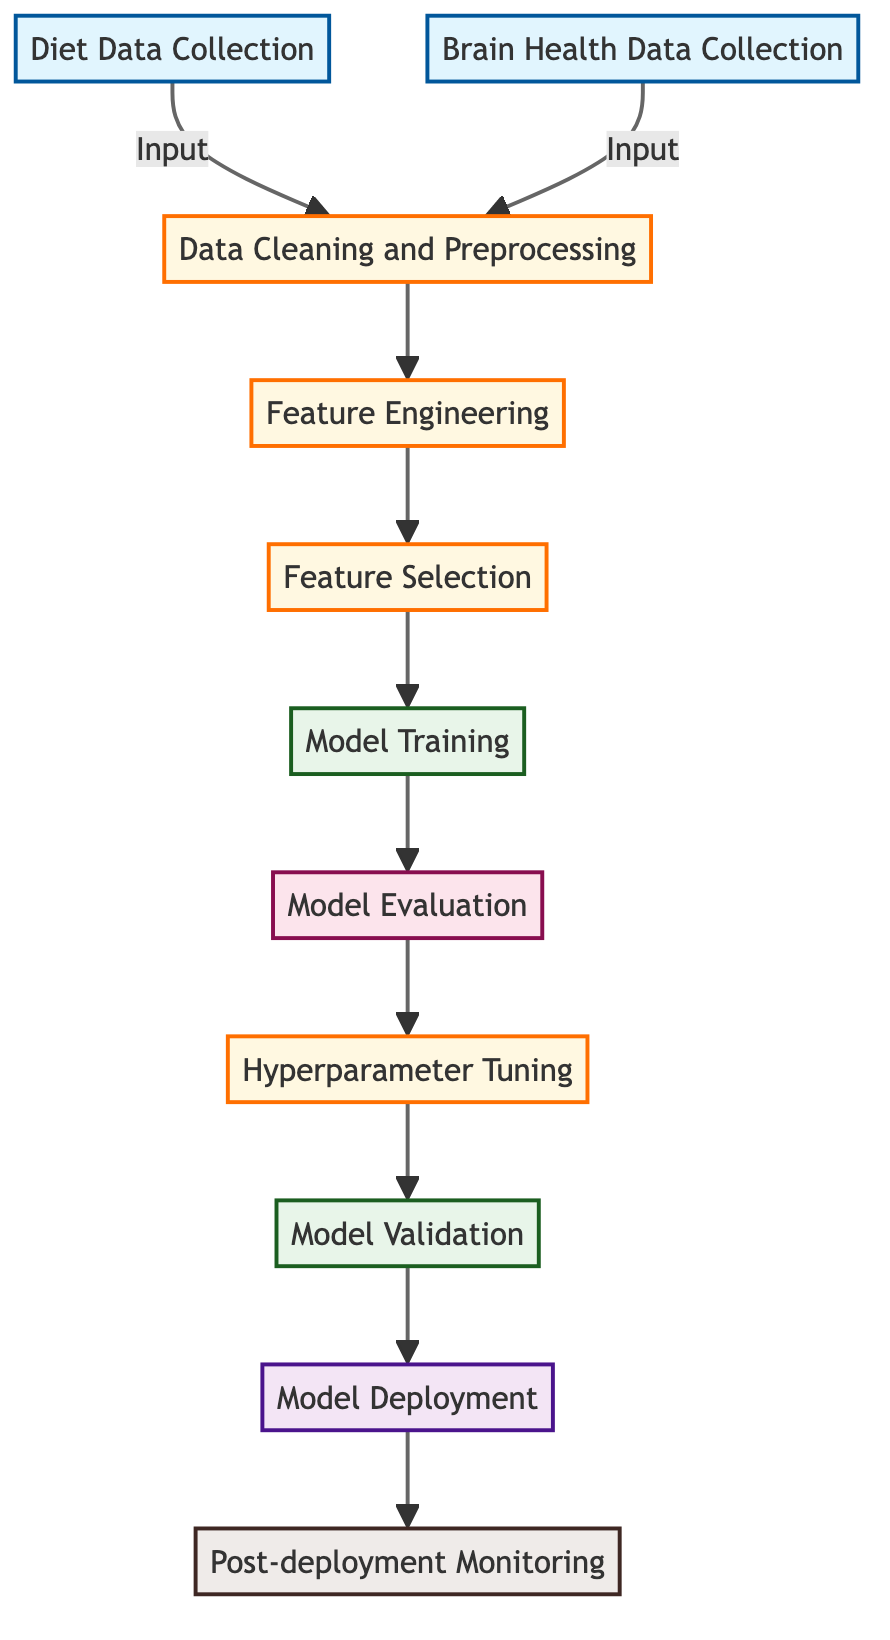What is the first step in the workflow? The first step in the workflow is "Diet Data Collection", which is represented as the first node in the flowchart.
Answer: Diet Data Collection How many data input nodes are there? There are two data input nodes in the diagram: "Diet Data Collection" and "Brain Health Data Collection".
Answer: 2 What is the last step in the workflow? The last step in the workflow is "Post-deployment Monitoring", indicated as the final node in the flowchart.
Answer: Post-deployment Monitoring Which node involves generating relevant features? The node involving generating relevant features is "Feature Engineering". This is connected to the data preprocessing steps and occurs after data cleaning.
Answer: Feature Engineering What is the main purpose of the "Model Evaluation" step? "Model Evaluation" serves the purpose of assessing the machine learning model's performance using various metrics. This is an essential step before further processing like hyperparameter tuning.
Answer: Evaluate model performance How many total processing steps are there? There are five processing steps in the workflow: "Data Cleaning and Preprocessing", "Feature Engineering", "Feature Selection", "Hyperparameter Tuning", and "Model Validation".
Answer: 5 What step follows "Model Training"? The step that follows "Model Training" is "Model Evaluation". This denotes the transition from the training phase to assessing the quality of the trained model.
Answer: Model Evaluation What is the function of "Hyperparameter Tuning"? "Hyperparameter Tuning" optimizes the model parameters to improve its performance, which is critical for ensuring the model generalizes well on unseen data.
Answer: Optimize model parameters What type of analysis is performed during "Feature Selection"? In "Feature Selection", statistical tests or algorithms are used to determine the most significant features impacting brain health, which directly influences the subsequent modeling steps.
Answer: Select significant features What does "Model Deployment" refer to? "Model Deployment" refers to the act of putting the predictive model into a production environment where it can make real-time predictions based on new data inputs.
Answer: Deploy the predictive model 